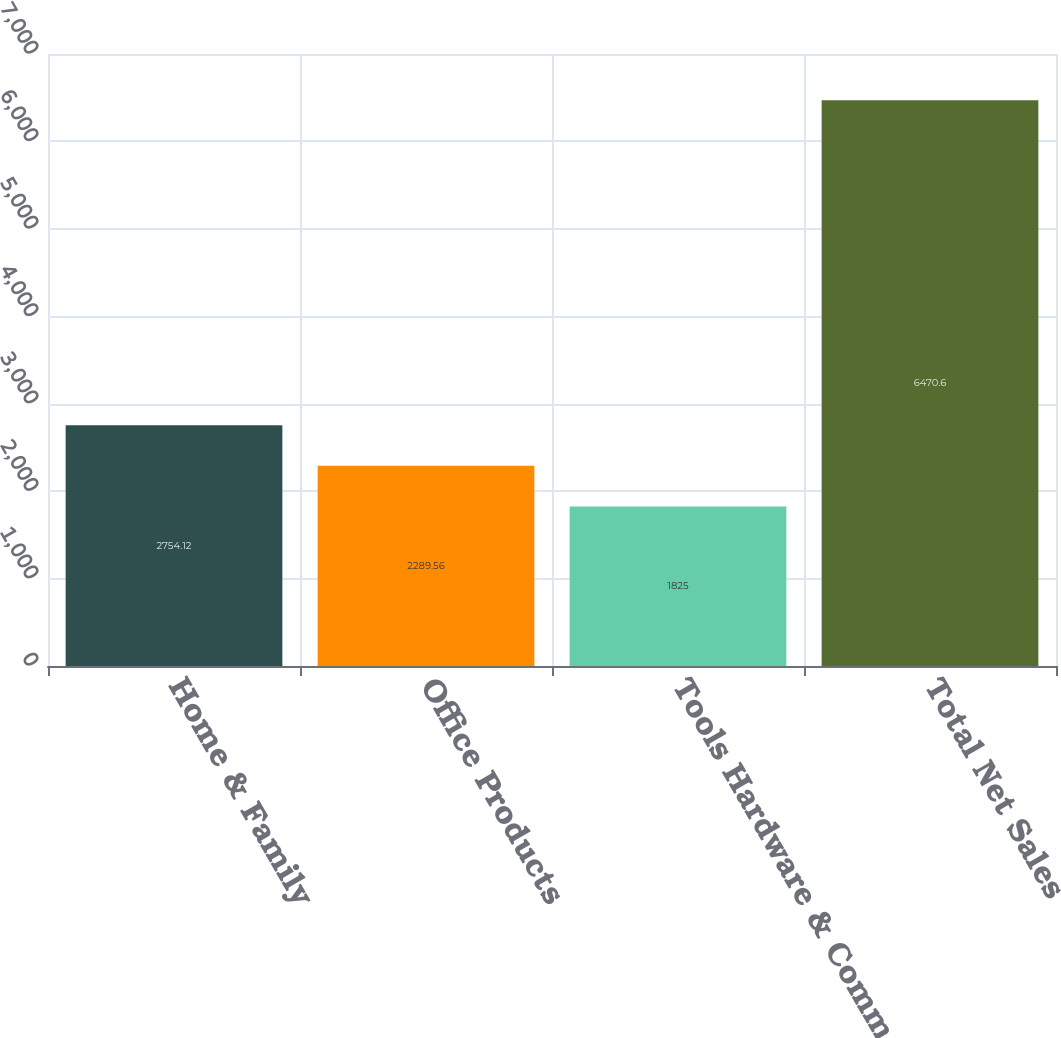<chart> <loc_0><loc_0><loc_500><loc_500><bar_chart><fcel>Home & Family<fcel>Office Products<fcel>Tools Hardware & Commercial<fcel>Total Net Sales<nl><fcel>2754.12<fcel>2289.56<fcel>1825<fcel>6470.6<nl></chart> 